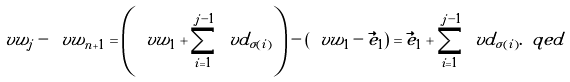Convert formula to latex. <formula><loc_0><loc_0><loc_500><loc_500>\ v w _ { j } - \ v w _ { n + 1 } = \left ( \ v w _ { 1 } + \sum _ { i = 1 } ^ { j - 1 } \ v d _ { \sigma ( i ) } \right ) - \left ( \ v w _ { 1 } - \vec { e } _ { 1 } \right ) = \vec { e } _ { 1 } + \sum _ { i = 1 } ^ { j - 1 } \ v d _ { \sigma ( i ) } . \ q e d</formula> 